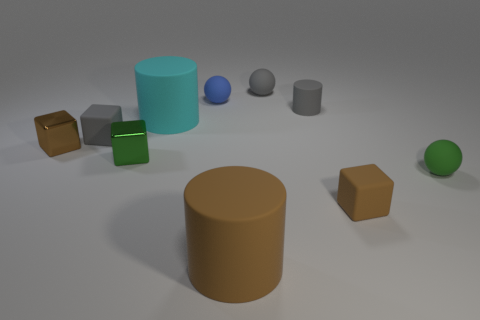Subtract all blue rubber balls. How many balls are left? 2 Subtract 2 balls. How many balls are left? 1 Subtract all gray cubes. How many cubes are left? 3 Subtract all cubes. How many objects are left? 6 Subtract all red cubes. How many cyan cylinders are left? 1 Add 2 metallic cubes. How many metallic cubes are left? 4 Add 8 small blue matte spheres. How many small blue matte spheres exist? 9 Subtract 0 purple spheres. How many objects are left? 10 Subtract all blue cubes. Subtract all green spheres. How many cubes are left? 4 Subtract all brown cylinders. Subtract all cyan matte objects. How many objects are left? 8 